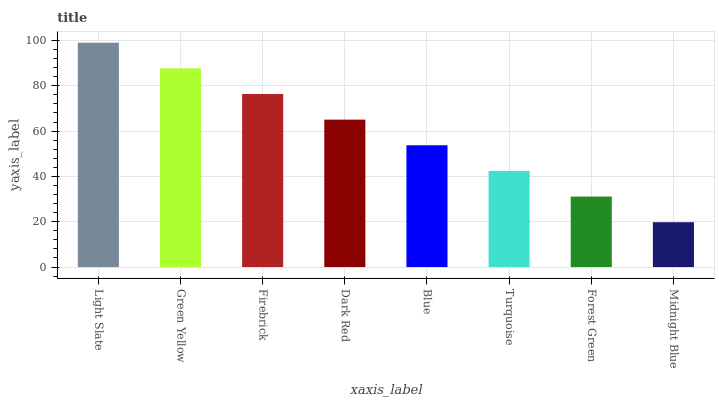Is Green Yellow the minimum?
Answer yes or no. No. Is Green Yellow the maximum?
Answer yes or no. No. Is Light Slate greater than Green Yellow?
Answer yes or no. Yes. Is Green Yellow less than Light Slate?
Answer yes or no. Yes. Is Green Yellow greater than Light Slate?
Answer yes or no. No. Is Light Slate less than Green Yellow?
Answer yes or no. No. Is Dark Red the high median?
Answer yes or no. Yes. Is Blue the low median?
Answer yes or no. Yes. Is Green Yellow the high median?
Answer yes or no. No. Is Midnight Blue the low median?
Answer yes or no. No. 